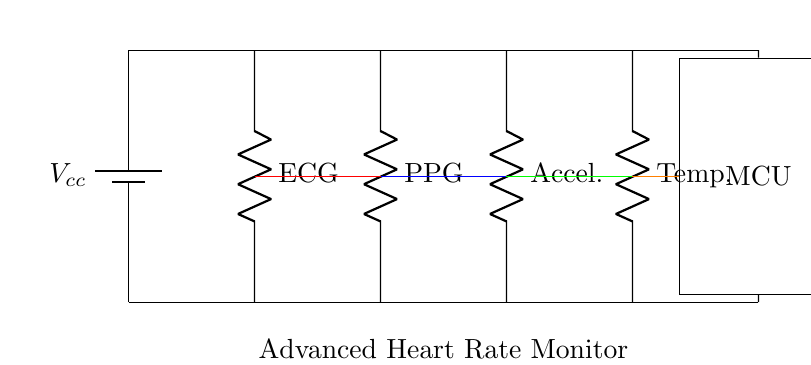What type of circuit is shown in the diagram? The circuit is a parallel circuit, which is indicated by the multiple branches connected to the same voltage source that share common voltage but may have different currents based on their resistances.
Answer: Parallel circuit How many sensors are connected in the circuit? The circuit shows four sensors connected in parallel, visible from the four individual components (ECG, PPG, Accelerometer, and Temperature) each having separate branches leading to the microcontroller.
Answer: Four sensors What is the main component that all sensors connect to? All sensors connect to the microcontroller, which is the rectangular component shown at the end of the main line, indicating it processes the data from each sensor.
Answer: Microcontroller Which sensor type is located second from the left? The second sensor from the left is the PPG sensor, identifiable by its label and position in the circuit diagram.
Answer: PPG What happens to the voltage across each sensor in a parallel circuit? In a parallel circuit, the voltage across each sensor remains constant and equal to the supply voltage (Vcc), which is also the same for all branches in the circuit.
Answer: Constant voltage If one sensor fails, what happens to the others? If one sensor fails, the others still function normally because they are connected in parallel, allowing them to maintain their operation independently.
Answer: Others continue functioning What is the function of the voltage source in this circuit? The voltage source provides the necessary power to all components in the circuit, ensuring that each sensor receives the same voltage to operate effectively.
Answer: Power supply 